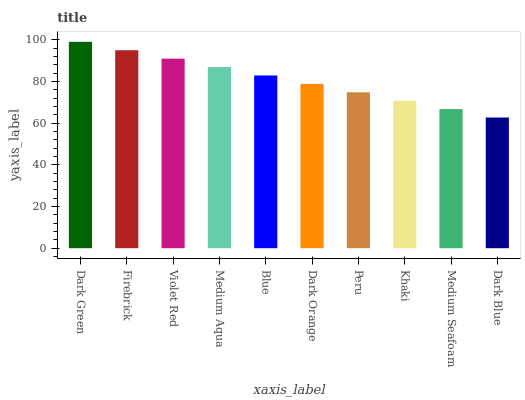Is Dark Blue the minimum?
Answer yes or no. Yes. Is Dark Green the maximum?
Answer yes or no. Yes. Is Firebrick the minimum?
Answer yes or no. No. Is Firebrick the maximum?
Answer yes or no. No. Is Dark Green greater than Firebrick?
Answer yes or no. Yes. Is Firebrick less than Dark Green?
Answer yes or no. Yes. Is Firebrick greater than Dark Green?
Answer yes or no. No. Is Dark Green less than Firebrick?
Answer yes or no. No. Is Blue the high median?
Answer yes or no. Yes. Is Dark Orange the low median?
Answer yes or no. Yes. Is Medium Aqua the high median?
Answer yes or no. No. Is Khaki the low median?
Answer yes or no. No. 